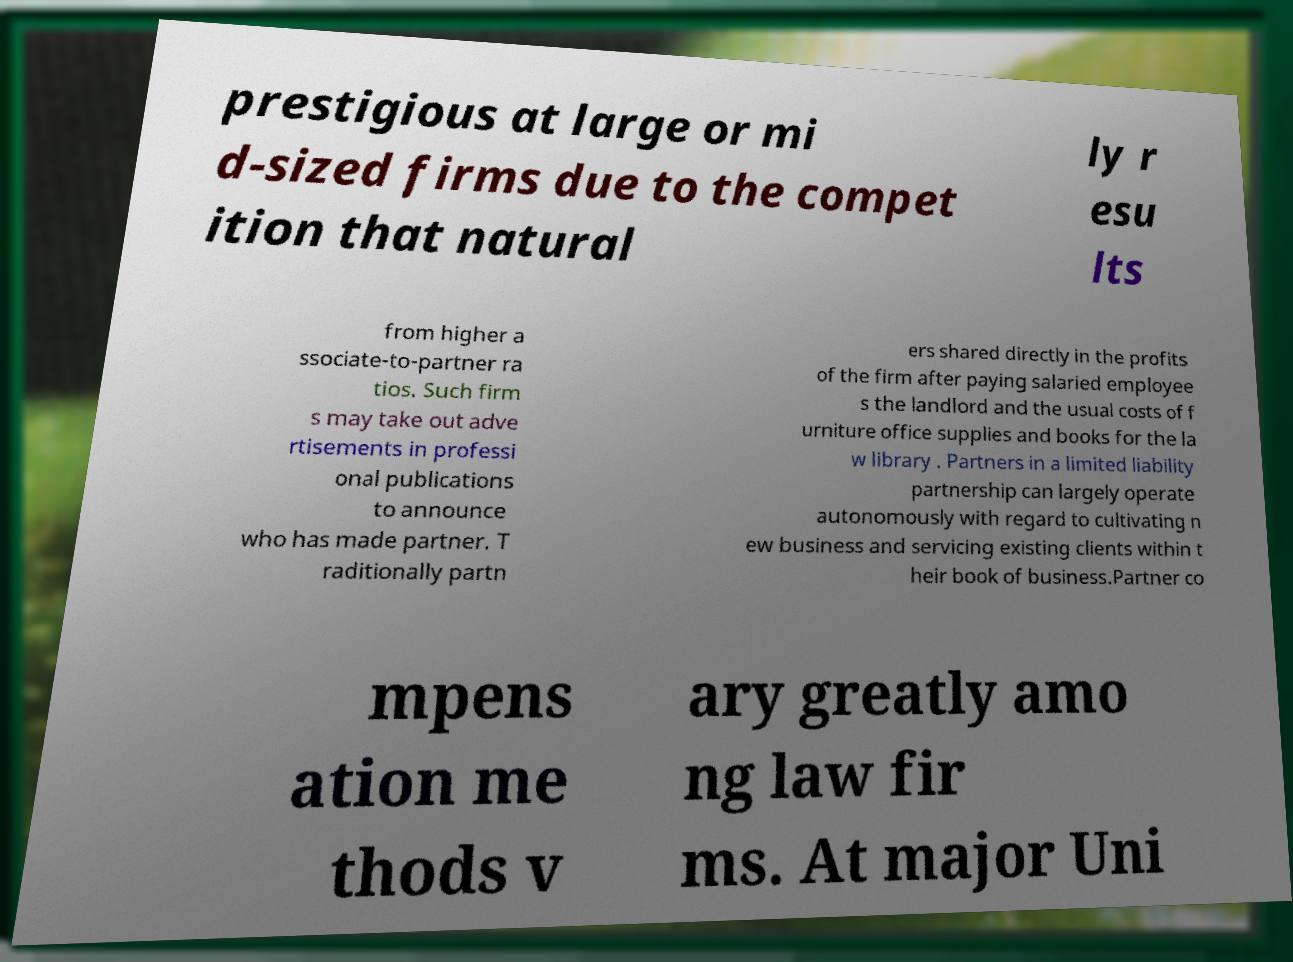What messages or text are displayed in this image? I need them in a readable, typed format. prestigious at large or mi d-sized firms due to the compet ition that natural ly r esu lts from higher a ssociate-to-partner ra tios. Such firm s may take out adve rtisements in professi onal publications to announce who has made partner. T raditionally partn ers shared directly in the profits of the firm after paying salaried employee s the landlord and the usual costs of f urniture office supplies and books for the la w library . Partners in a limited liability partnership can largely operate autonomously with regard to cultivating n ew business and servicing existing clients within t heir book of business.Partner co mpens ation me thods v ary greatly amo ng law fir ms. At major Uni 